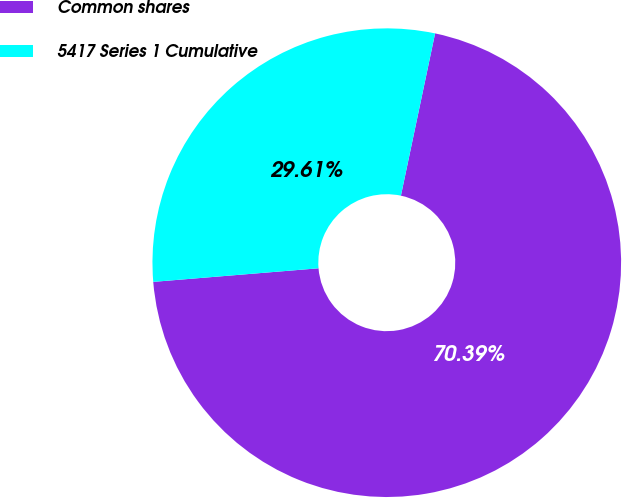Convert chart to OTSL. <chart><loc_0><loc_0><loc_500><loc_500><pie_chart><fcel>Common shares<fcel>5417 Series 1 Cumulative<nl><fcel>70.39%<fcel>29.61%<nl></chart> 